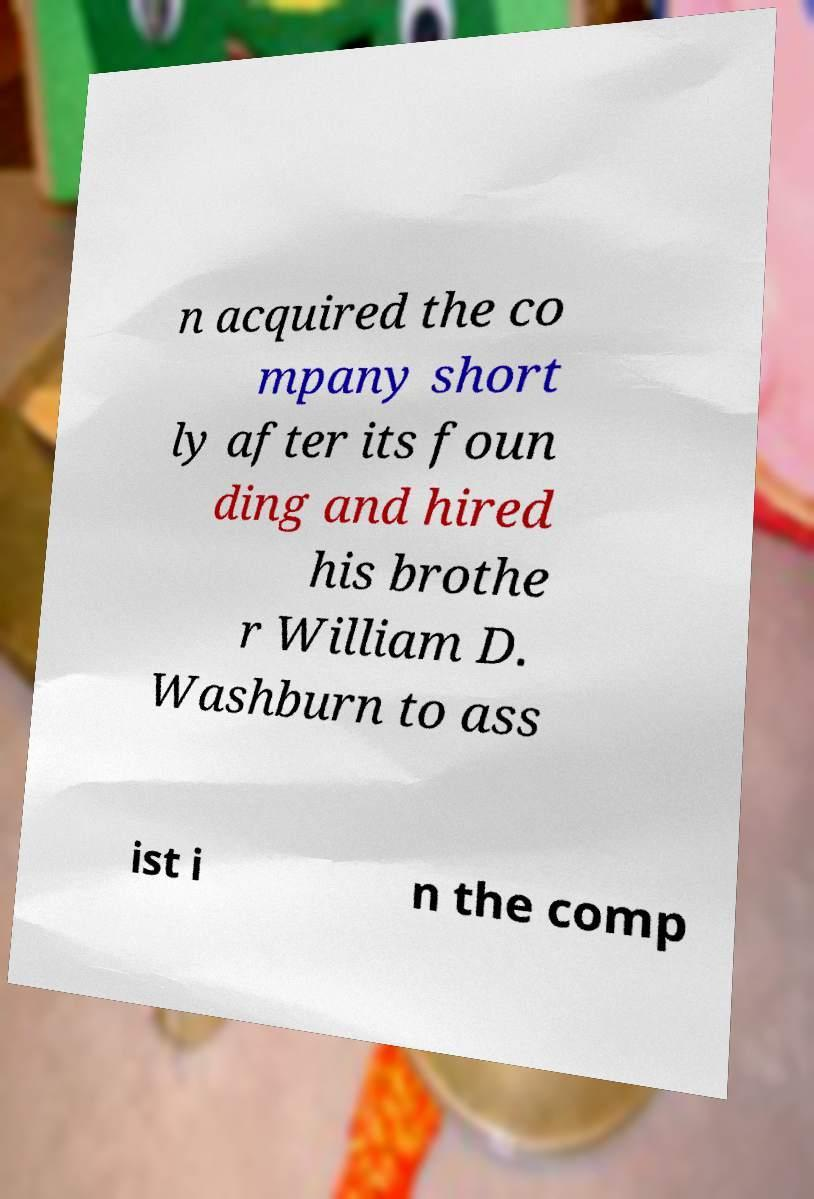Please identify and transcribe the text found in this image. n acquired the co mpany short ly after its foun ding and hired his brothe r William D. Washburn to ass ist i n the comp 